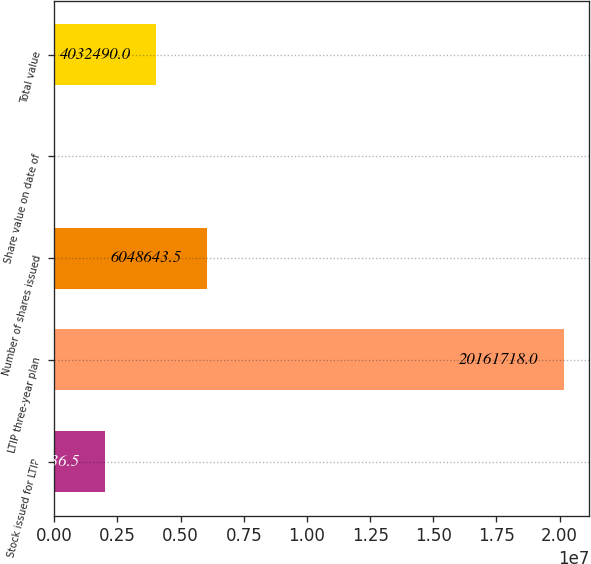Convert chart to OTSL. <chart><loc_0><loc_0><loc_500><loc_500><bar_chart><fcel>Stock issued for LTIP<fcel>LTIP three-year plan<fcel>Number of shares issued<fcel>Share value on date of<fcel>Total value<nl><fcel>2.01634e+06<fcel>2.01617e+07<fcel>6.04864e+06<fcel>183<fcel>4.03249e+06<nl></chart> 